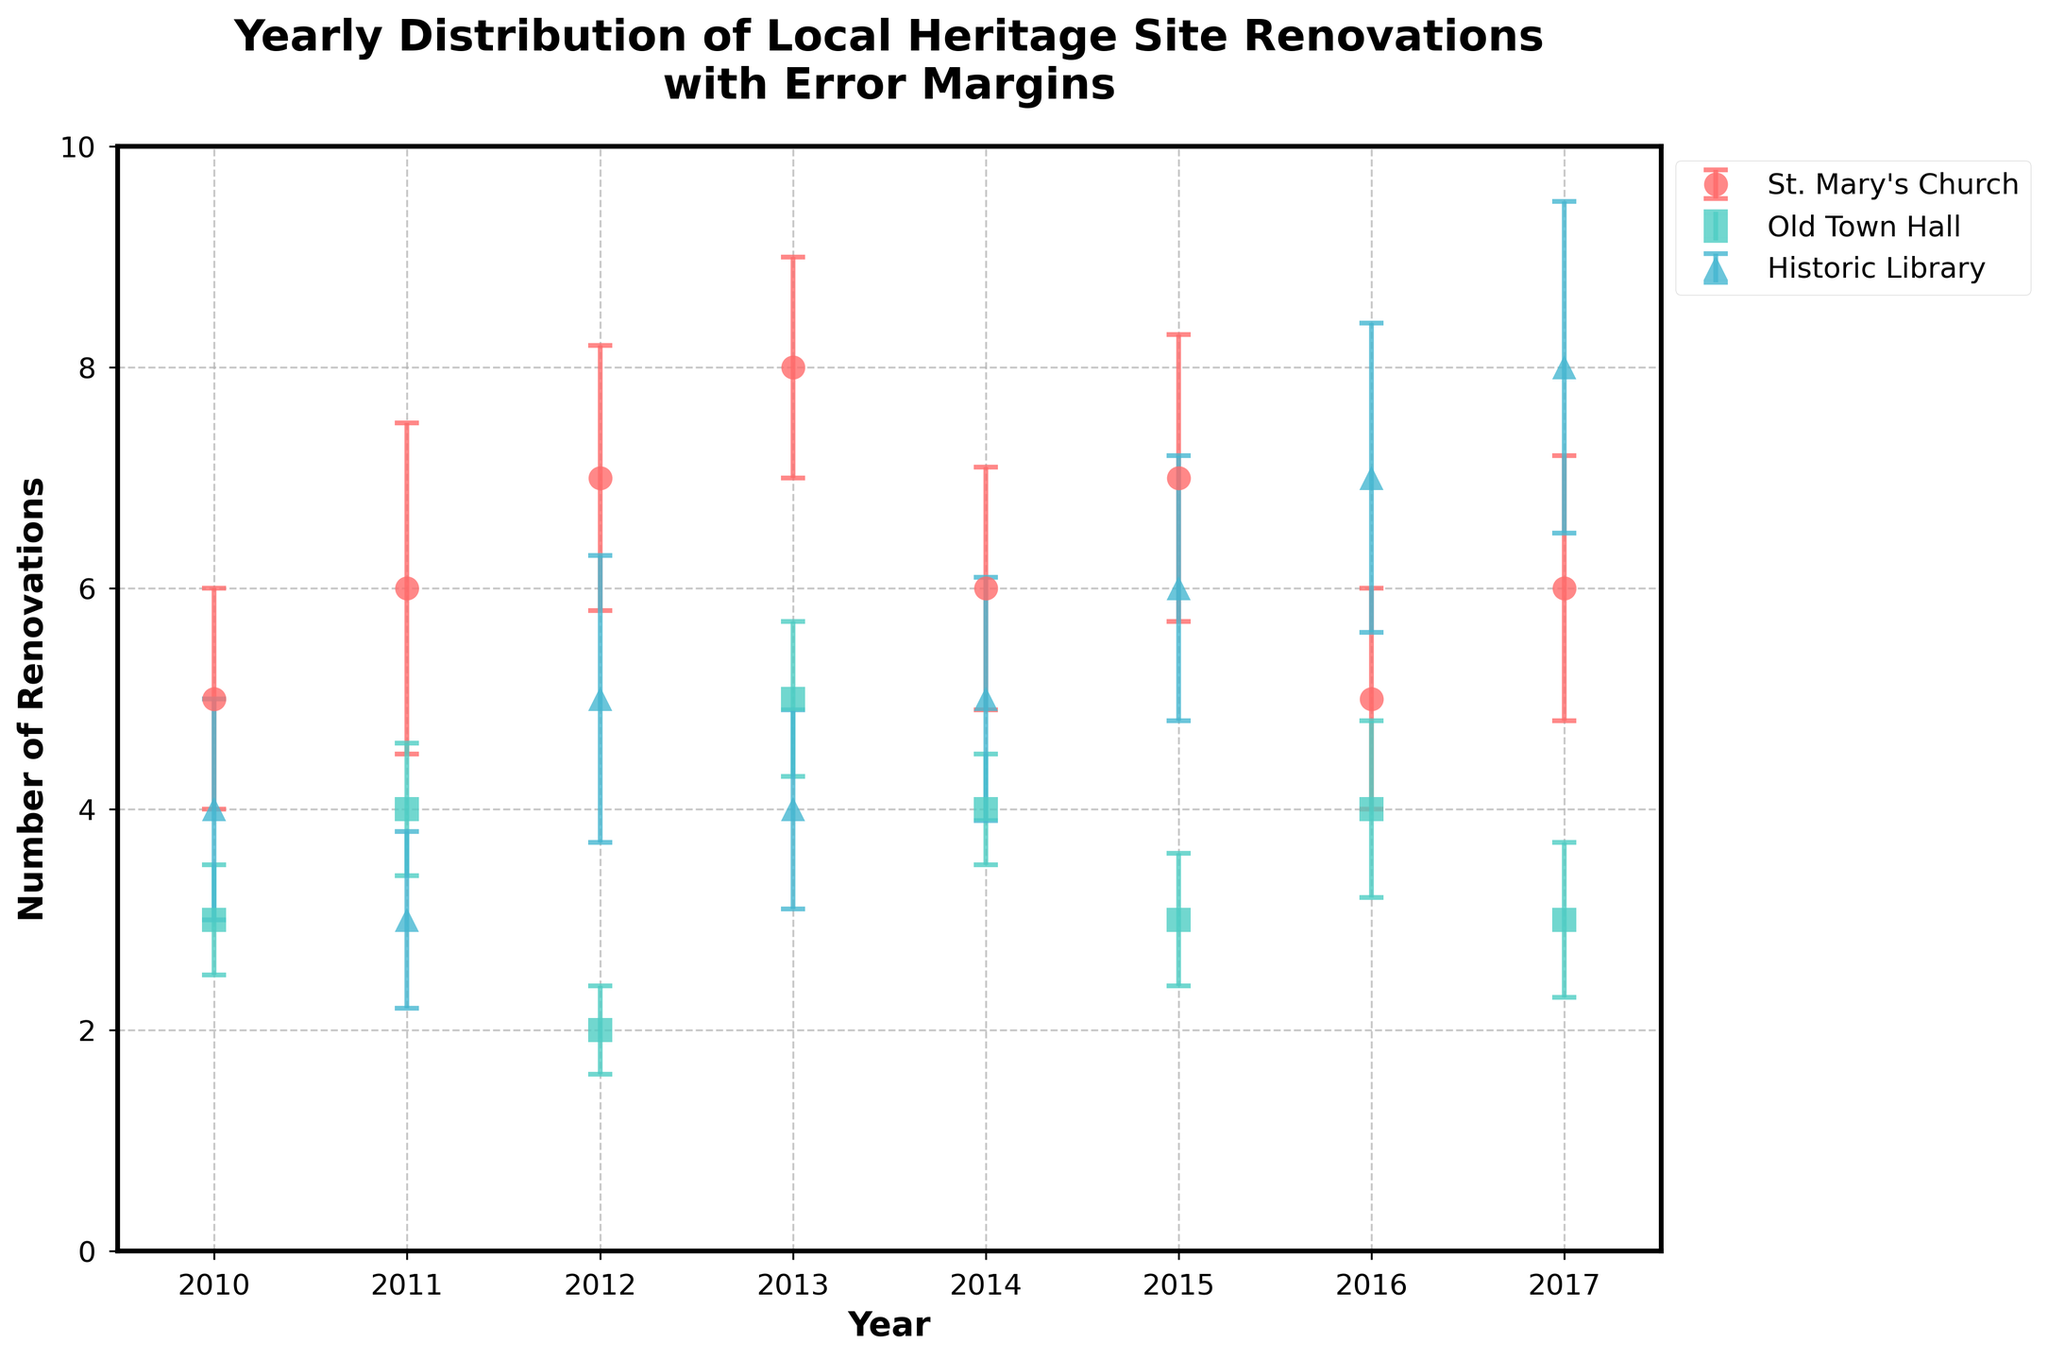What is the highest number of renovations for St. Mary's Church in any year? Look at the data points for St. Mary's Church on the plot and identify the highest value. The highest number of renovations is 8 in 2013.
Answer: 8 How many heritage sites are represented in the plot? Count the number of distinct markers or colors used in the plot, each representing a different heritage site. There are three distinct heritage sites: St. Mary's Church, Old Town Hall, and Historic Library.
Answer: 3 Which year had the lowest number of renovations for the Old Town Hall? Examine the data points for Old Town Hall and identify the year with the lowest renovation count. The year with the lowest number of renovations for the Old Town Hall is 2012 with 2 renovations.
Answer: 2012 What is the average number of renovations for the Historic Library over the years? Add the number of renovations for the Historic Library across all years and divide by the number of years. The total renovations (4+3+5+4+5+6+7+8) over 8 years come to 42. The average is 42/8 = 5.25.
Answer: 5.25 Between 2010 and 2017, which site had the most consistent number of renovations? Look at the error bars to evaluate the variability. The site with the smallest and most consistent error bars over the years is the Old Town Hall.
Answer: Old Town Hall In which year did the sum of renovations for all sites peak? Calculate the sum of renovations for all sites for each year and identify the year with the highest total. The sums are as follows: 
2010: 12 
2011: 13 
2012: 14 
2013: 17 
2014: 15 
2015: 16 
2016: 16 
2017: 17 
The peak year is 2013 and 2017 with a total of 17 renovations.
Answer: 2013, 2017 What is the trend of renovations for St. Mary's Church from 2010 to 2017? Observe the direction of the data points for St. Mary's Church over the years. The trend appears to generally increase from 2010 to 2013, then fluctuates with a slight decline in 2016, and increases again in 2017.
Answer: Increasing with fluctuations How does the variability (error margins) of renovations for the Historic Library change over time? Look at the error bars for the Historic Library and note any changes or patterns in their length. The error margins for the Historic Library seem to generally increase over time, indicating growing variability.
Answer: Increase over time Which site shows the greatest increase in renovations from one year to another? Compare the year-on-year changes in renovations for each site. The Historic Library shows an increase from 2016 to 2017 by 1 renovation, and from 2015 to 2016 by 1 renovation.
Answer: Historic Library 